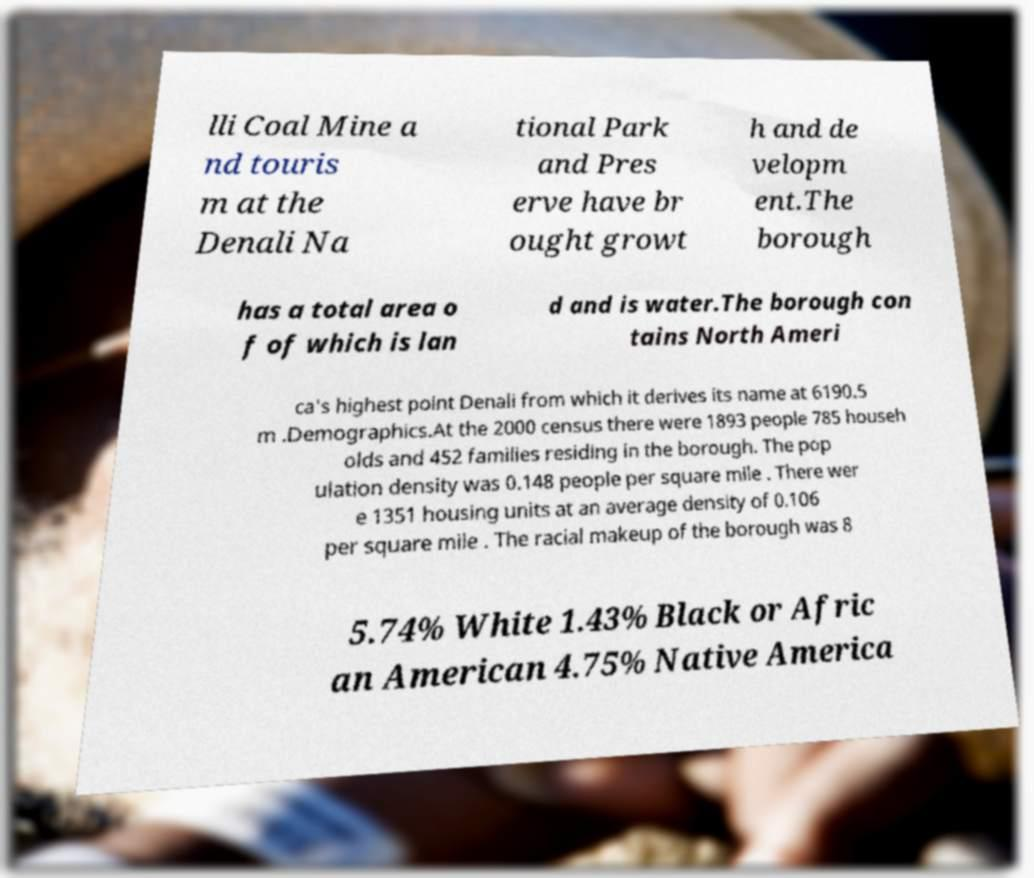What messages or text are displayed in this image? I need them in a readable, typed format. lli Coal Mine a nd touris m at the Denali Na tional Park and Pres erve have br ought growt h and de velopm ent.The borough has a total area o f of which is lan d and is water.The borough con tains North Ameri ca's highest point Denali from which it derives its name at 6190.5 m .Demographics.At the 2000 census there were 1893 people 785 househ olds and 452 families residing in the borough. The pop ulation density was 0.148 people per square mile . There wer e 1351 housing units at an average density of 0.106 per square mile . The racial makeup of the borough was 8 5.74% White 1.43% Black or Afric an American 4.75% Native America 